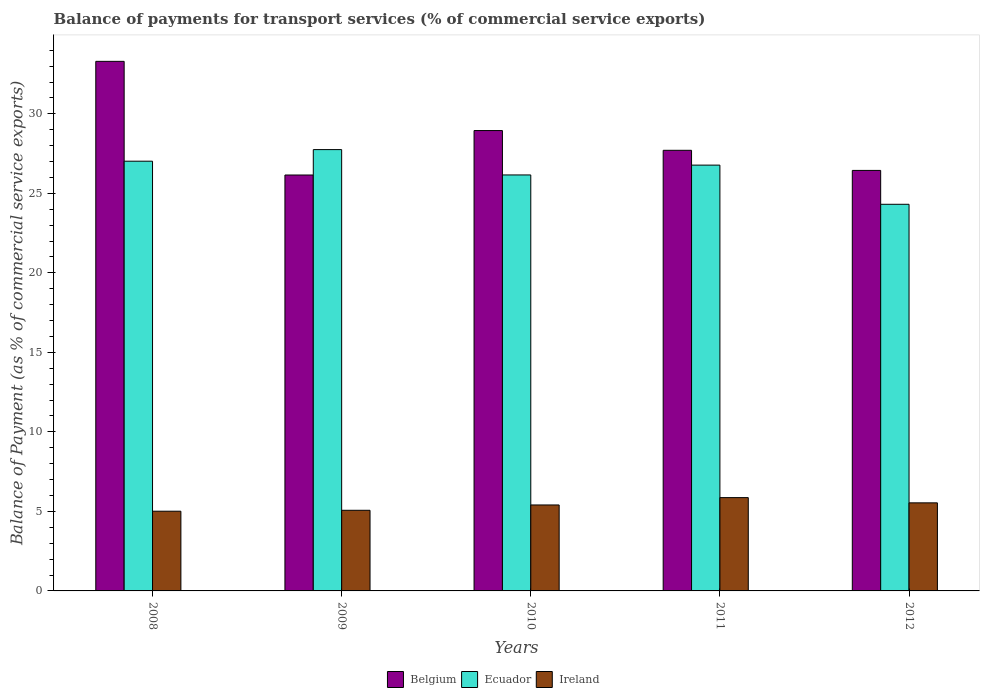How many different coloured bars are there?
Give a very brief answer. 3. Are the number of bars per tick equal to the number of legend labels?
Keep it short and to the point. Yes. Are the number of bars on each tick of the X-axis equal?
Your response must be concise. Yes. How many bars are there on the 3rd tick from the right?
Your answer should be compact. 3. What is the label of the 2nd group of bars from the left?
Make the answer very short. 2009. What is the balance of payments for transport services in Ireland in 2009?
Offer a very short reply. 5.07. Across all years, what is the maximum balance of payments for transport services in Ireland?
Offer a very short reply. 5.87. Across all years, what is the minimum balance of payments for transport services in Ireland?
Provide a short and direct response. 5.01. In which year was the balance of payments for transport services in Ecuador minimum?
Offer a very short reply. 2012. What is the total balance of payments for transport services in Belgium in the graph?
Provide a short and direct response. 142.55. What is the difference between the balance of payments for transport services in Ecuador in 2010 and that in 2012?
Keep it short and to the point. 1.84. What is the difference between the balance of payments for transport services in Ireland in 2010 and the balance of payments for transport services in Ecuador in 2012?
Give a very brief answer. -18.91. What is the average balance of payments for transport services in Belgium per year?
Provide a succinct answer. 28.51. In the year 2011, what is the difference between the balance of payments for transport services in Ecuador and balance of payments for transport services in Ireland?
Your answer should be very brief. 20.91. What is the ratio of the balance of payments for transport services in Ireland in 2010 to that in 2011?
Your answer should be very brief. 0.92. What is the difference between the highest and the second highest balance of payments for transport services in Ireland?
Provide a short and direct response. 0.33. What is the difference between the highest and the lowest balance of payments for transport services in Ireland?
Your answer should be compact. 0.85. Is the sum of the balance of payments for transport services in Belgium in 2008 and 2011 greater than the maximum balance of payments for transport services in Ireland across all years?
Make the answer very short. Yes. What does the 2nd bar from the left in 2011 represents?
Offer a very short reply. Ecuador. What does the 2nd bar from the right in 2010 represents?
Your answer should be compact. Ecuador. Is it the case that in every year, the sum of the balance of payments for transport services in Belgium and balance of payments for transport services in Ecuador is greater than the balance of payments for transport services in Ireland?
Offer a very short reply. Yes. Are all the bars in the graph horizontal?
Ensure brevity in your answer.  No. How many years are there in the graph?
Ensure brevity in your answer.  5. Are the values on the major ticks of Y-axis written in scientific E-notation?
Your answer should be very brief. No. Does the graph contain grids?
Offer a terse response. No. How are the legend labels stacked?
Provide a short and direct response. Horizontal. What is the title of the graph?
Make the answer very short. Balance of payments for transport services (% of commercial service exports). Does "East Asia (all income levels)" appear as one of the legend labels in the graph?
Keep it short and to the point. No. What is the label or title of the Y-axis?
Your response must be concise. Balance of Payment (as % of commercial service exports). What is the Balance of Payment (as % of commercial service exports) of Belgium in 2008?
Give a very brief answer. 33.3. What is the Balance of Payment (as % of commercial service exports) of Ecuador in 2008?
Give a very brief answer. 27.02. What is the Balance of Payment (as % of commercial service exports) in Ireland in 2008?
Provide a short and direct response. 5.01. What is the Balance of Payment (as % of commercial service exports) of Belgium in 2009?
Your answer should be compact. 26.15. What is the Balance of Payment (as % of commercial service exports) in Ecuador in 2009?
Your answer should be very brief. 27.75. What is the Balance of Payment (as % of commercial service exports) in Ireland in 2009?
Ensure brevity in your answer.  5.07. What is the Balance of Payment (as % of commercial service exports) in Belgium in 2010?
Your answer should be compact. 28.95. What is the Balance of Payment (as % of commercial service exports) of Ecuador in 2010?
Your response must be concise. 26.16. What is the Balance of Payment (as % of commercial service exports) in Ireland in 2010?
Provide a short and direct response. 5.4. What is the Balance of Payment (as % of commercial service exports) in Belgium in 2011?
Ensure brevity in your answer.  27.71. What is the Balance of Payment (as % of commercial service exports) of Ecuador in 2011?
Offer a very short reply. 26.78. What is the Balance of Payment (as % of commercial service exports) of Ireland in 2011?
Provide a succinct answer. 5.87. What is the Balance of Payment (as % of commercial service exports) of Belgium in 2012?
Your answer should be compact. 26.44. What is the Balance of Payment (as % of commercial service exports) in Ecuador in 2012?
Your response must be concise. 24.31. What is the Balance of Payment (as % of commercial service exports) of Ireland in 2012?
Your answer should be compact. 5.54. Across all years, what is the maximum Balance of Payment (as % of commercial service exports) of Belgium?
Your answer should be very brief. 33.3. Across all years, what is the maximum Balance of Payment (as % of commercial service exports) in Ecuador?
Your response must be concise. 27.75. Across all years, what is the maximum Balance of Payment (as % of commercial service exports) in Ireland?
Your response must be concise. 5.87. Across all years, what is the minimum Balance of Payment (as % of commercial service exports) of Belgium?
Offer a very short reply. 26.15. Across all years, what is the minimum Balance of Payment (as % of commercial service exports) in Ecuador?
Provide a succinct answer. 24.31. Across all years, what is the minimum Balance of Payment (as % of commercial service exports) of Ireland?
Keep it short and to the point. 5.01. What is the total Balance of Payment (as % of commercial service exports) in Belgium in the graph?
Keep it short and to the point. 142.55. What is the total Balance of Payment (as % of commercial service exports) of Ecuador in the graph?
Make the answer very short. 132.02. What is the total Balance of Payment (as % of commercial service exports) of Ireland in the graph?
Your response must be concise. 26.89. What is the difference between the Balance of Payment (as % of commercial service exports) in Belgium in 2008 and that in 2009?
Ensure brevity in your answer.  7.15. What is the difference between the Balance of Payment (as % of commercial service exports) of Ecuador in 2008 and that in 2009?
Make the answer very short. -0.73. What is the difference between the Balance of Payment (as % of commercial service exports) in Ireland in 2008 and that in 2009?
Ensure brevity in your answer.  -0.06. What is the difference between the Balance of Payment (as % of commercial service exports) of Belgium in 2008 and that in 2010?
Your answer should be very brief. 4.35. What is the difference between the Balance of Payment (as % of commercial service exports) of Ecuador in 2008 and that in 2010?
Your response must be concise. 0.86. What is the difference between the Balance of Payment (as % of commercial service exports) in Ireland in 2008 and that in 2010?
Offer a terse response. -0.39. What is the difference between the Balance of Payment (as % of commercial service exports) in Belgium in 2008 and that in 2011?
Your answer should be very brief. 5.59. What is the difference between the Balance of Payment (as % of commercial service exports) in Ecuador in 2008 and that in 2011?
Make the answer very short. 0.25. What is the difference between the Balance of Payment (as % of commercial service exports) in Ireland in 2008 and that in 2011?
Provide a short and direct response. -0.85. What is the difference between the Balance of Payment (as % of commercial service exports) in Belgium in 2008 and that in 2012?
Your answer should be compact. 6.86. What is the difference between the Balance of Payment (as % of commercial service exports) of Ecuador in 2008 and that in 2012?
Give a very brief answer. 2.71. What is the difference between the Balance of Payment (as % of commercial service exports) of Ireland in 2008 and that in 2012?
Offer a very short reply. -0.53. What is the difference between the Balance of Payment (as % of commercial service exports) of Belgium in 2009 and that in 2010?
Give a very brief answer. -2.8. What is the difference between the Balance of Payment (as % of commercial service exports) in Ecuador in 2009 and that in 2010?
Your answer should be very brief. 1.59. What is the difference between the Balance of Payment (as % of commercial service exports) in Ireland in 2009 and that in 2010?
Your answer should be compact. -0.33. What is the difference between the Balance of Payment (as % of commercial service exports) in Belgium in 2009 and that in 2011?
Ensure brevity in your answer.  -1.55. What is the difference between the Balance of Payment (as % of commercial service exports) in Ecuador in 2009 and that in 2011?
Ensure brevity in your answer.  0.98. What is the difference between the Balance of Payment (as % of commercial service exports) in Ireland in 2009 and that in 2011?
Offer a terse response. -0.8. What is the difference between the Balance of Payment (as % of commercial service exports) in Belgium in 2009 and that in 2012?
Give a very brief answer. -0.29. What is the difference between the Balance of Payment (as % of commercial service exports) of Ecuador in 2009 and that in 2012?
Your answer should be very brief. 3.44. What is the difference between the Balance of Payment (as % of commercial service exports) in Ireland in 2009 and that in 2012?
Your answer should be very brief. -0.47. What is the difference between the Balance of Payment (as % of commercial service exports) in Belgium in 2010 and that in 2011?
Offer a very short reply. 1.24. What is the difference between the Balance of Payment (as % of commercial service exports) of Ecuador in 2010 and that in 2011?
Offer a very short reply. -0.62. What is the difference between the Balance of Payment (as % of commercial service exports) in Ireland in 2010 and that in 2011?
Keep it short and to the point. -0.46. What is the difference between the Balance of Payment (as % of commercial service exports) of Belgium in 2010 and that in 2012?
Offer a terse response. 2.51. What is the difference between the Balance of Payment (as % of commercial service exports) in Ecuador in 2010 and that in 2012?
Your response must be concise. 1.84. What is the difference between the Balance of Payment (as % of commercial service exports) in Ireland in 2010 and that in 2012?
Your response must be concise. -0.13. What is the difference between the Balance of Payment (as % of commercial service exports) of Belgium in 2011 and that in 2012?
Keep it short and to the point. 1.26. What is the difference between the Balance of Payment (as % of commercial service exports) of Ecuador in 2011 and that in 2012?
Give a very brief answer. 2.46. What is the difference between the Balance of Payment (as % of commercial service exports) of Ireland in 2011 and that in 2012?
Make the answer very short. 0.33. What is the difference between the Balance of Payment (as % of commercial service exports) of Belgium in 2008 and the Balance of Payment (as % of commercial service exports) of Ecuador in 2009?
Give a very brief answer. 5.55. What is the difference between the Balance of Payment (as % of commercial service exports) of Belgium in 2008 and the Balance of Payment (as % of commercial service exports) of Ireland in 2009?
Ensure brevity in your answer.  28.23. What is the difference between the Balance of Payment (as % of commercial service exports) in Ecuador in 2008 and the Balance of Payment (as % of commercial service exports) in Ireland in 2009?
Your answer should be very brief. 21.95. What is the difference between the Balance of Payment (as % of commercial service exports) of Belgium in 2008 and the Balance of Payment (as % of commercial service exports) of Ecuador in 2010?
Provide a short and direct response. 7.14. What is the difference between the Balance of Payment (as % of commercial service exports) of Belgium in 2008 and the Balance of Payment (as % of commercial service exports) of Ireland in 2010?
Give a very brief answer. 27.9. What is the difference between the Balance of Payment (as % of commercial service exports) in Ecuador in 2008 and the Balance of Payment (as % of commercial service exports) in Ireland in 2010?
Ensure brevity in your answer.  21.62. What is the difference between the Balance of Payment (as % of commercial service exports) in Belgium in 2008 and the Balance of Payment (as % of commercial service exports) in Ecuador in 2011?
Offer a very short reply. 6.52. What is the difference between the Balance of Payment (as % of commercial service exports) in Belgium in 2008 and the Balance of Payment (as % of commercial service exports) in Ireland in 2011?
Your answer should be compact. 27.43. What is the difference between the Balance of Payment (as % of commercial service exports) in Ecuador in 2008 and the Balance of Payment (as % of commercial service exports) in Ireland in 2011?
Make the answer very short. 21.15. What is the difference between the Balance of Payment (as % of commercial service exports) of Belgium in 2008 and the Balance of Payment (as % of commercial service exports) of Ecuador in 2012?
Provide a short and direct response. 8.99. What is the difference between the Balance of Payment (as % of commercial service exports) of Belgium in 2008 and the Balance of Payment (as % of commercial service exports) of Ireland in 2012?
Your response must be concise. 27.76. What is the difference between the Balance of Payment (as % of commercial service exports) in Ecuador in 2008 and the Balance of Payment (as % of commercial service exports) in Ireland in 2012?
Make the answer very short. 21.48. What is the difference between the Balance of Payment (as % of commercial service exports) in Belgium in 2009 and the Balance of Payment (as % of commercial service exports) in Ecuador in 2010?
Your answer should be compact. -0. What is the difference between the Balance of Payment (as % of commercial service exports) in Belgium in 2009 and the Balance of Payment (as % of commercial service exports) in Ireland in 2010?
Your answer should be very brief. 20.75. What is the difference between the Balance of Payment (as % of commercial service exports) of Ecuador in 2009 and the Balance of Payment (as % of commercial service exports) of Ireland in 2010?
Provide a short and direct response. 22.35. What is the difference between the Balance of Payment (as % of commercial service exports) in Belgium in 2009 and the Balance of Payment (as % of commercial service exports) in Ecuador in 2011?
Your answer should be very brief. -0.62. What is the difference between the Balance of Payment (as % of commercial service exports) of Belgium in 2009 and the Balance of Payment (as % of commercial service exports) of Ireland in 2011?
Provide a succinct answer. 20.29. What is the difference between the Balance of Payment (as % of commercial service exports) in Ecuador in 2009 and the Balance of Payment (as % of commercial service exports) in Ireland in 2011?
Keep it short and to the point. 21.88. What is the difference between the Balance of Payment (as % of commercial service exports) of Belgium in 2009 and the Balance of Payment (as % of commercial service exports) of Ecuador in 2012?
Keep it short and to the point. 1.84. What is the difference between the Balance of Payment (as % of commercial service exports) of Belgium in 2009 and the Balance of Payment (as % of commercial service exports) of Ireland in 2012?
Make the answer very short. 20.62. What is the difference between the Balance of Payment (as % of commercial service exports) in Ecuador in 2009 and the Balance of Payment (as % of commercial service exports) in Ireland in 2012?
Make the answer very short. 22.21. What is the difference between the Balance of Payment (as % of commercial service exports) in Belgium in 2010 and the Balance of Payment (as % of commercial service exports) in Ecuador in 2011?
Provide a short and direct response. 2.17. What is the difference between the Balance of Payment (as % of commercial service exports) in Belgium in 2010 and the Balance of Payment (as % of commercial service exports) in Ireland in 2011?
Give a very brief answer. 23.08. What is the difference between the Balance of Payment (as % of commercial service exports) in Ecuador in 2010 and the Balance of Payment (as % of commercial service exports) in Ireland in 2011?
Your response must be concise. 20.29. What is the difference between the Balance of Payment (as % of commercial service exports) in Belgium in 2010 and the Balance of Payment (as % of commercial service exports) in Ecuador in 2012?
Ensure brevity in your answer.  4.64. What is the difference between the Balance of Payment (as % of commercial service exports) in Belgium in 2010 and the Balance of Payment (as % of commercial service exports) in Ireland in 2012?
Give a very brief answer. 23.41. What is the difference between the Balance of Payment (as % of commercial service exports) of Ecuador in 2010 and the Balance of Payment (as % of commercial service exports) of Ireland in 2012?
Provide a succinct answer. 20.62. What is the difference between the Balance of Payment (as % of commercial service exports) of Belgium in 2011 and the Balance of Payment (as % of commercial service exports) of Ecuador in 2012?
Make the answer very short. 3.39. What is the difference between the Balance of Payment (as % of commercial service exports) in Belgium in 2011 and the Balance of Payment (as % of commercial service exports) in Ireland in 2012?
Make the answer very short. 22.17. What is the difference between the Balance of Payment (as % of commercial service exports) of Ecuador in 2011 and the Balance of Payment (as % of commercial service exports) of Ireland in 2012?
Provide a short and direct response. 21.24. What is the average Balance of Payment (as % of commercial service exports) in Belgium per year?
Make the answer very short. 28.51. What is the average Balance of Payment (as % of commercial service exports) in Ecuador per year?
Provide a short and direct response. 26.4. What is the average Balance of Payment (as % of commercial service exports) in Ireland per year?
Your response must be concise. 5.38. In the year 2008, what is the difference between the Balance of Payment (as % of commercial service exports) of Belgium and Balance of Payment (as % of commercial service exports) of Ecuador?
Make the answer very short. 6.28. In the year 2008, what is the difference between the Balance of Payment (as % of commercial service exports) of Belgium and Balance of Payment (as % of commercial service exports) of Ireland?
Your response must be concise. 28.29. In the year 2008, what is the difference between the Balance of Payment (as % of commercial service exports) of Ecuador and Balance of Payment (as % of commercial service exports) of Ireland?
Ensure brevity in your answer.  22.01. In the year 2009, what is the difference between the Balance of Payment (as % of commercial service exports) in Belgium and Balance of Payment (as % of commercial service exports) in Ecuador?
Your response must be concise. -1.6. In the year 2009, what is the difference between the Balance of Payment (as % of commercial service exports) of Belgium and Balance of Payment (as % of commercial service exports) of Ireland?
Ensure brevity in your answer.  21.08. In the year 2009, what is the difference between the Balance of Payment (as % of commercial service exports) in Ecuador and Balance of Payment (as % of commercial service exports) in Ireland?
Your answer should be compact. 22.68. In the year 2010, what is the difference between the Balance of Payment (as % of commercial service exports) of Belgium and Balance of Payment (as % of commercial service exports) of Ecuador?
Offer a very short reply. 2.79. In the year 2010, what is the difference between the Balance of Payment (as % of commercial service exports) in Belgium and Balance of Payment (as % of commercial service exports) in Ireland?
Ensure brevity in your answer.  23.54. In the year 2010, what is the difference between the Balance of Payment (as % of commercial service exports) in Ecuador and Balance of Payment (as % of commercial service exports) in Ireland?
Make the answer very short. 20.75. In the year 2011, what is the difference between the Balance of Payment (as % of commercial service exports) of Belgium and Balance of Payment (as % of commercial service exports) of Ecuador?
Offer a very short reply. 0.93. In the year 2011, what is the difference between the Balance of Payment (as % of commercial service exports) of Belgium and Balance of Payment (as % of commercial service exports) of Ireland?
Offer a very short reply. 21.84. In the year 2011, what is the difference between the Balance of Payment (as % of commercial service exports) of Ecuador and Balance of Payment (as % of commercial service exports) of Ireland?
Give a very brief answer. 20.91. In the year 2012, what is the difference between the Balance of Payment (as % of commercial service exports) of Belgium and Balance of Payment (as % of commercial service exports) of Ecuador?
Offer a very short reply. 2.13. In the year 2012, what is the difference between the Balance of Payment (as % of commercial service exports) in Belgium and Balance of Payment (as % of commercial service exports) in Ireland?
Make the answer very short. 20.9. In the year 2012, what is the difference between the Balance of Payment (as % of commercial service exports) in Ecuador and Balance of Payment (as % of commercial service exports) in Ireland?
Your answer should be compact. 18.77. What is the ratio of the Balance of Payment (as % of commercial service exports) of Belgium in 2008 to that in 2009?
Offer a very short reply. 1.27. What is the ratio of the Balance of Payment (as % of commercial service exports) of Ecuador in 2008 to that in 2009?
Give a very brief answer. 0.97. What is the ratio of the Balance of Payment (as % of commercial service exports) in Ireland in 2008 to that in 2009?
Make the answer very short. 0.99. What is the ratio of the Balance of Payment (as % of commercial service exports) of Belgium in 2008 to that in 2010?
Give a very brief answer. 1.15. What is the ratio of the Balance of Payment (as % of commercial service exports) of Ecuador in 2008 to that in 2010?
Give a very brief answer. 1.03. What is the ratio of the Balance of Payment (as % of commercial service exports) in Ireland in 2008 to that in 2010?
Your answer should be compact. 0.93. What is the ratio of the Balance of Payment (as % of commercial service exports) in Belgium in 2008 to that in 2011?
Provide a short and direct response. 1.2. What is the ratio of the Balance of Payment (as % of commercial service exports) of Ecuador in 2008 to that in 2011?
Ensure brevity in your answer.  1.01. What is the ratio of the Balance of Payment (as % of commercial service exports) of Ireland in 2008 to that in 2011?
Offer a very short reply. 0.85. What is the ratio of the Balance of Payment (as % of commercial service exports) in Belgium in 2008 to that in 2012?
Offer a very short reply. 1.26. What is the ratio of the Balance of Payment (as % of commercial service exports) of Ecuador in 2008 to that in 2012?
Make the answer very short. 1.11. What is the ratio of the Balance of Payment (as % of commercial service exports) in Ireland in 2008 to that in 2012?
Your answer should be compact. 0.91. What is the ratio of the Balance of Payment (as % of commercial service exports) of Belgium in 2009 to that in 2010?
Make the answer very short. 0.9. What is the ratio of the Balance of Payment (as % of commercial service exports) in Ecuador in 2009 to that in 2010?
Your answer should be compact. 1.06. What is the ratio of the Balance of Payment (as % of commercial service exports) of Ireland in 2009 to that in 2010?
Offer a very short reply. 0.94. What is the ratio of the Balance of Payment (as % of commercial service exports) in Belgium in 2009 to that in 2011?
Make the answer very short. 0.94. What is the ratio of the Balance of Payment (as % of commercial service exports) in Ecuador in 2009 to that in 2011?
Your answer should be very brief. 1.04. What is the ratio of the Balance of Payment (as % of commercial service exports) in Ireland in 2009 to that in 2011?
Your answer should be compact. 0.86. What is the ratio of the Balance of Payment (as % of commercial service exports) of Ecuador in 2009 to that in 2012?
Offer a terse response. 1.14. What is the ratio of the Balance of Payment (as % of commercial service exports) of Ireland in 2009 to that in 2012?
Your answer should be very brief. 0.92. What is the ratio of the Balance of Payment (as % of commercial service exports) of Belgium in 2010 to that in 2011?
Provide a succinct answer. 1.04. What is the ratio of the Balance of Payment (as % of commercial service exports) of Ecuador in 2010 to that in 2011?
Offer a terse response. 0.98. What is the ratio of the Balance of Payment (as % of commercial service exports) of Ireland in 2010 to that in 2011?
Provide a succinct answer. 0.92. What is the ratio of the Balance of Payment (as % of commercial service exports) of Belgium in 2010 to that in 2012?
Offer a very short reply. 1.09. What is the ratio of the Balance of Payment (as % of commercial service exports) of Ecuador in 2010 to that in 2012?
Your answer should be compact. 1.08. What is the ratio of the Balance of Payment (as % of commercial service exports) of Ireland in 2010 to that in 2012?
Provide a succinct answer. 0.98. What is the ratio of the Balance of Payment (as % of commercial service exports) of Belgium in 2011 to that in 2012?
Your answer should be very brief. 1.05. What is the ratio of the Balance of Payment (as % of commercial service exports) in Ecuador in 2011 to that in 2012?
Provide a succinct answer. 1.1. What is the ratio of the Balance of Payment (as % of commercial service exports) of Ireland in 2011 to that in 2012?
Give a very brief answer. 1.06. What is the difference between the highest and the second highest Balance of Payment (as % of commercial service exports) in Belgium?
Keep it short and to the point. 4.35. What is the difference between the highest and the second highest Balance of Payment (as % of commercial service exports) of Ecuador?
Your answer should be very brief. 0.73. What is the difference between the highest and the second highest Balance of Payment (as % of commercial service exports) of Ireland?
Give a very brief answer. 0.33. What is the difference between the highest and the lowest Balance of Payment (as % of commercial service exports) of Belgium?
Your response must be concise. 7.15. What is the difference between the highest and the lowest Balance of Payment (as % of commercial service exports) in Ecuador?
Your answer should be very brief. 3.44. What is the difference between the highest and the lowest Balance of Payment (as % of commercial service exports) of Ireland?
Provide a succinct answer. 0.85. 